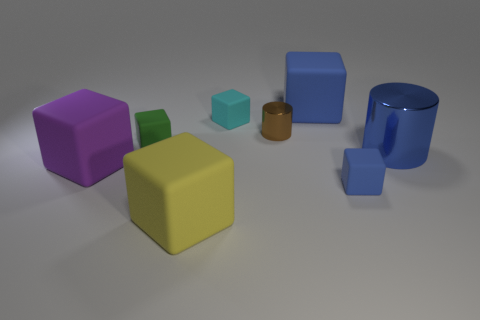The big thing that is the same material as the brown cylinder is what shape?
Make the answer very short. Cylinder. There is a blue thing that is to the right of the blue matte block in front of the shiny cylinder that is in front of the brown cylinder; what is its material?
Give a very brief answer. Metal. What number of things are big yellow rubber cubes in front of the tiny cyan matte block or tiny shiny things?
Offer a terse response. 2. How many other things are there of the same shape as the tiny green object?
Provide a succinct answer. 5. Are there more things that are left of the big blue cube than small brown things?
Your response must be concise. Yes. There is a yellow matte object that is the same shape as the green rubber object; what size is it?
Your answer should be very brief. Large. The blue shiny object is what shape?
Your answer should be very brief. Cylinder. What is the shape of the cyan thing that is the same size as the green rubber thing?
Your response must be concise. Cube. Is there any other thing that is the same color as the small metal cylinder?
Offer a very short reply. No. What is the size of the purple cube that is made of the same material as the green block?
Provide a short and direct response. Large. 